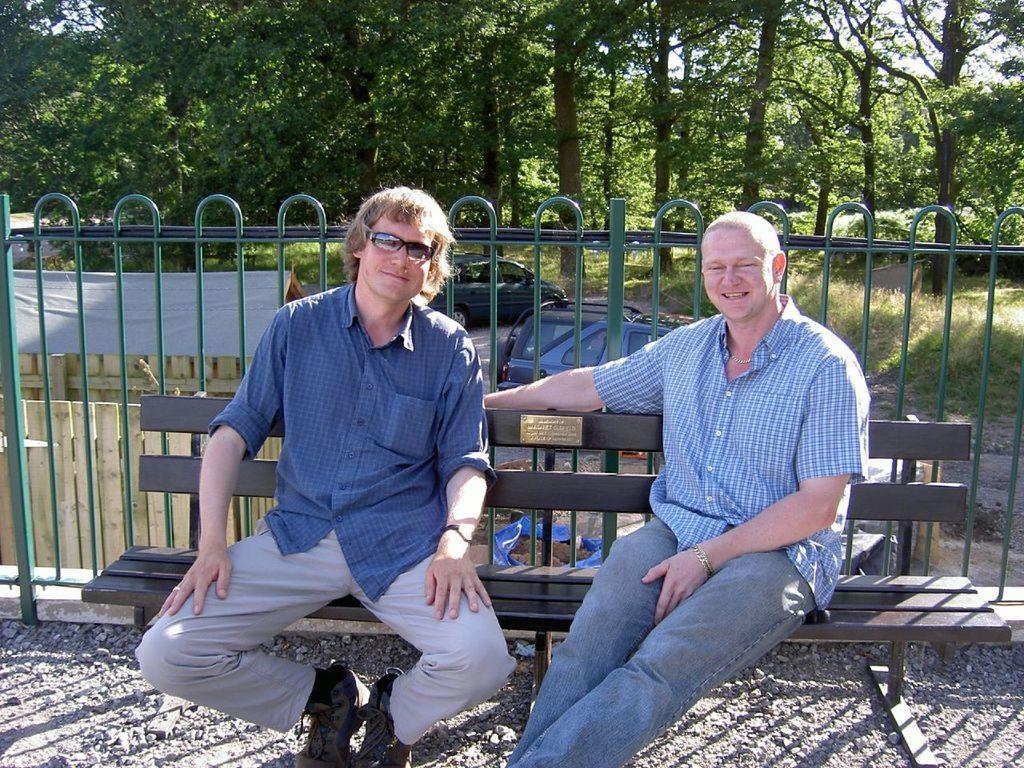What are the people in the image doing? The people in the image are sitting on a bench. What is located behind the bench? There is a fence at the back of the bench. What can be seen on the ground in the image? There are vehicles on the ground in the image. What type of vegetation is present in the image? There are trees in the image. What type of structure is visible in the image? There is a shed in the image. What objects are made of sticks in the image? There are sticks in the image. What is covering something in the image? There is a cover in the image. What is the income of the people sitting on the bench in the image? There is no information about the income of the people in the image. What is the aftermath of the event that occurred in the image? There is no event mentioned in the image, so it's not possible to determine the aftermath. 